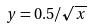<formula> <loc_0><loc_0><loc_500><loc_500>y = 0 . 5 / \sqrt { x }</formula> 